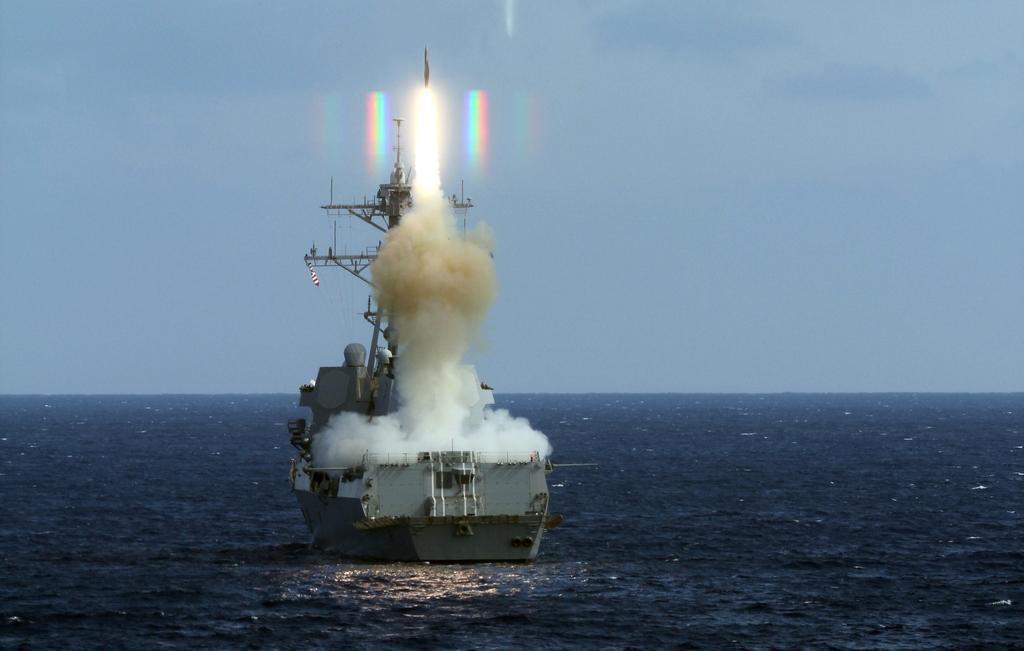In one or two sentences, can you explain what this image depicts? In the picture we can see an ocean which is blue in color water on it, we can see a ship with some poles and smoke in it and in the background we can see a sky. 